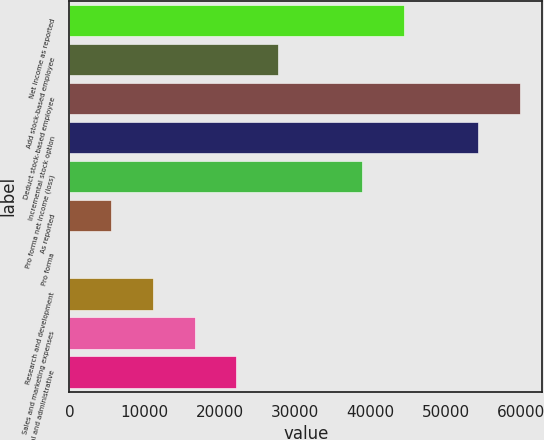Convert chart. <chart><loc_0><loc_0><loc_500><loc_500><bar_chart><fcel>Net income as reported<fcel>Add stock-based employee<fcel>Deduct stock-based employee<fcel>Incremental stock option<fcel>Pro forma net income (loss)<fcel>As reported<fcel>Pro forma<fcel>Research and development<fcel>Sales and marketing expenses<fcel>General and administrative<nl><fcel>44368.8<fcel>27730.6<fcel>59807.1<fcel>54261<fcel>38822.7<fcel>5546.24<fcel>0.16<fcel>11092.3<fcel>16638.4<fcel>22184.5<nl></chart> 